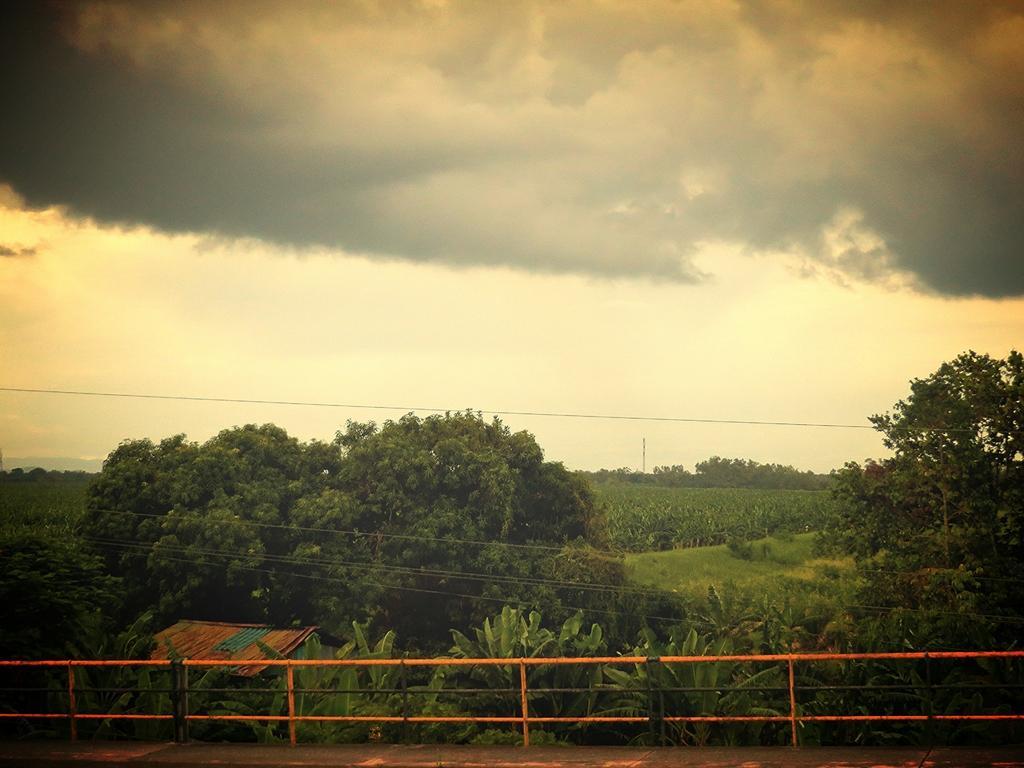How would you summarize this image in a sentence or two? In this picture we can see a fence from left to right. There are a few plants, house, wire on top and some trees are visible in the background. Sky is cloudy. 